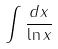<formula> <loc_0><loc_0><loc_500><loc_500>\int \frac { d x } { \ln x }</formula> 